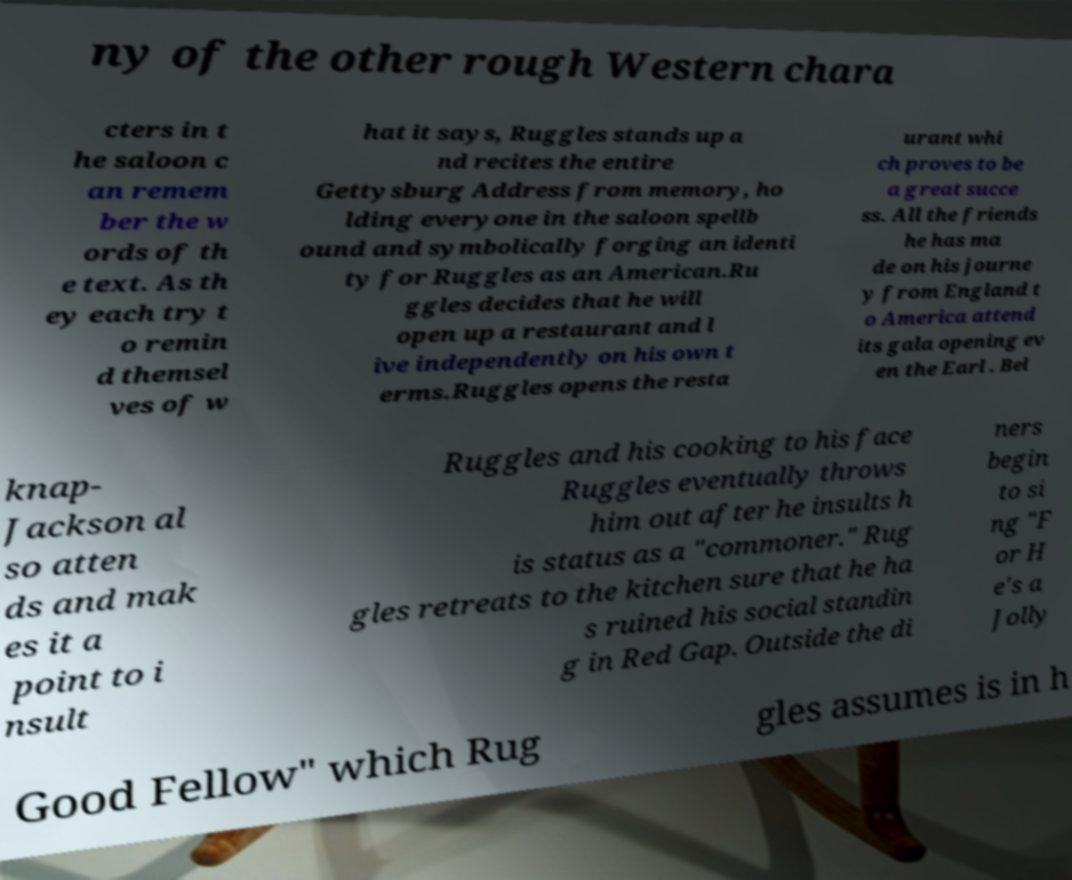Can you read and provide the text displayed in the image?This photo seems to have some interesting text. Can you extract and type it out for me? ny of the other rough Western chara cters in t he saloon c an remem ber the w ords of th e text. As th ey each try t o remin d themsel ves of w hat it says, Ruggles stands up a nd recites the entire Gettysburg Address from memory, ho lding everyone in the saloon spellb ound and symbolically forging an identi ty for Ruggles as an American.Ru ggles decides that he will open up a restaurant and l ive independently on his own t erms.Ruggles opens the resta urant whi ch proves to be a great succe ss. All the friends he has ma de on his journe y from England t o America attend its gala opening ev en the Earl . Bel knap- Jackson al so atten ds and mak es it a point to i nsult Ruggles and his cooking to his face Ruggles eventually throws him out after he insults h is status as a "commoner." Rug gles retreats to the kitchen sure that he ha s ruined his social standin g in Red Gap. Outside the di ners begin to si ng "F or H e's a Jolly Good Fellow" which Rug gles assumes is in h 